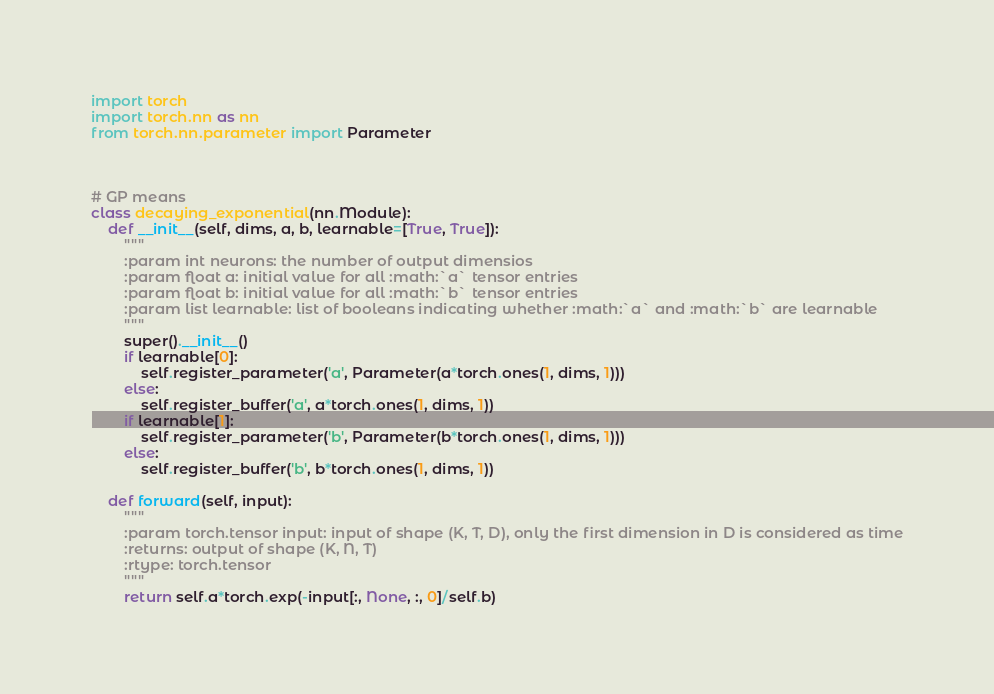Convert code to text. <code><loc_0><loc_0><loc_500><loc_500><_Python_>import torch
import torch.nn as nn
from torch.nn.parameter import Parameter



# GP means
class decaying_exponential(nn.Module):
    def __init__(self, dims, a, b, learnable=[True, True]):
        """
        :param int neurons: the number of output dimensios
        :param float a: initial value for all :math:`a` tensor entries
        :param float b: initial value for all :math:`b` tensor entries
        :param list learnable: list of booleans indicating whether :math:`a` and :math:`b` are learnable
        """
        super().__init__()
        if learnable[0]:
            self.register_parameter('a', Parameter(a*torch.ones(1, dims, 1)))
        else:
            self.register_buffer('a', a*torch.ones(1, dims, 1))
        if learnable[1]:
            self.register_parameter('b', Parameter(b*torch.ones(1, dims, 1)))
        else:
            self.register_buffer('b', b*torch.ones(1, dims, 1))
        
    def forward(self, input):
        """
        :param torch.tensor input: input of shape (K, T, D), only the first dimension in D is considered as time
        :returns: output of shape (K, N, T) 
        :rtype: torch.tensor
        """
        return self.a*torch.exp(-input[:, None, :, 0]/self.b)</code> 